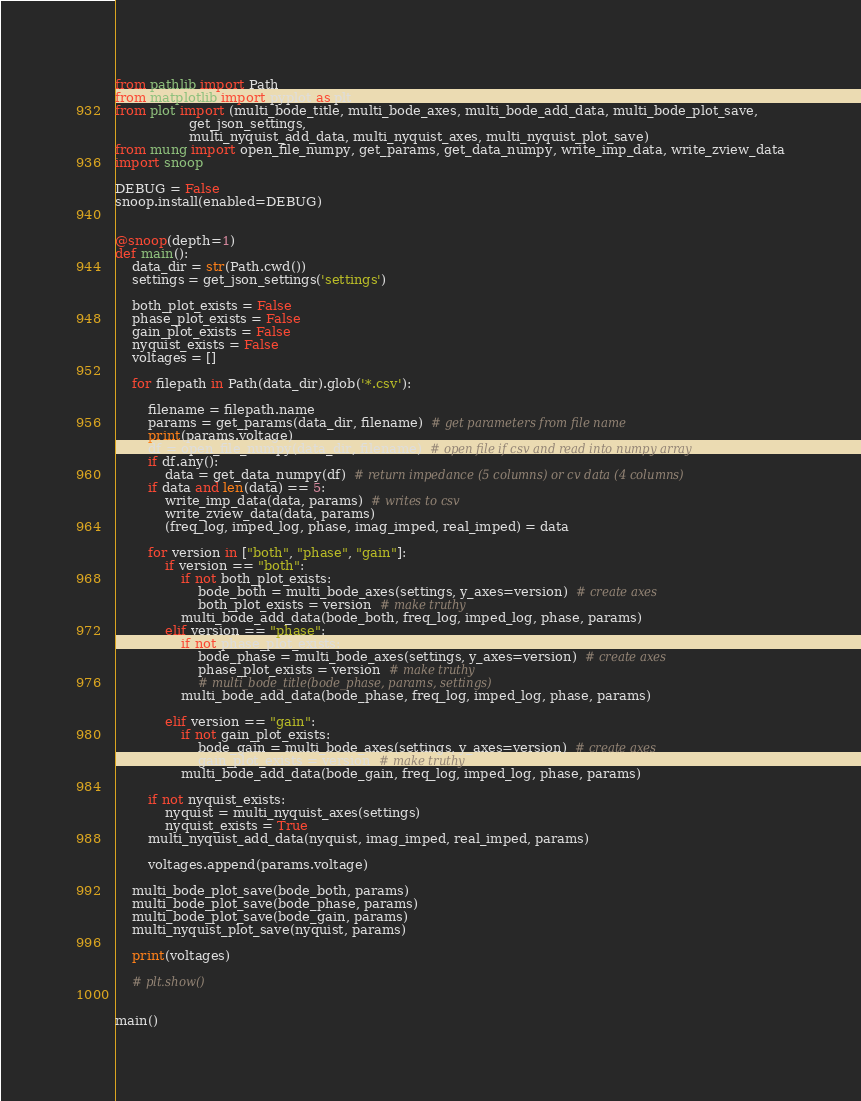Convert code to text. <code><loc_0><loc_0><loc_500><loc_500><_Python_>from pathlib import Path
from matplotlib import pyplot as plt
from plot import (multi_bode_title, multi_bode_axes, multi_bode_add_data, multi_bode_plot_save,
                  get_json_settings,
                  multi_nyquist_add_data, multi_nyquist_axes, multi_nyquist_plot_save)
from mung import open_file_numpy, get_params, get_data_numpy, write_imp_data, write_zview_data
import snoop

DEBUG = False
snoop.install(enabled=DEBUG)


@snoop(depth=1)
def main():
    data_dir = str(Path.cwd())
    settings = get_json_settings('settings')

    both_plot_exists = False
    phase_plot_exists = False
    gain_plot_exists = False
    nyquist_exists = False
    voltages = []

    for filepath in Path(data_dir).glob('*.csv'):

        filename = filepath.name
        params = get_params(data_dir, filename)  # get parameters from file name
        print(params.voltage)
        df = open_file_numpy(data_dir, filename)  # open file if csv and read into numpy array
        if df.any():
            data = get_data_numpy(df)  # return impedance (5 columns) or cv data (4 columns)
        if data and len(data) == 5:
            write_imp_data(data, params)  # writes to csv
            write_zview_data(data, params)
            (freq_log, imped_log, phase, imag_imped, real_imped) = data

        for version in ["both", "phase", "gain"]:
            if version == "both":
                if not both_plot_exists:
                    bode_both = multi_bode_axes(settings, y_axes=version)  # create axes
                    both_plot_exists = version  # make truthy
                multi_bode_add_data(bode_both, freq_log, imped_log, phase, params)
            elif version == "phase":
                if not phase_plot_exists:
                    bode_phase = multi_bode_axes(settings, y_axes=version)  # create axes
                    phase_plot_exists = version  # make truthy
                    # multi_bode_title(bode_phase, params, settings)
                multi_bode_add_data(bode_phase, freq_log, imped_log, phase, params)

            elif version == "gain":
                if not gain_plot_exists:
                    bode_gain = multi_bode_axes(settings, y_axes=version)  # create axes
                    gain_plot_exists = version  # make truthy
                multi_bode_add_data(bode_gain, freq_log, imped_log, phase, params)

        if not nyquist_exists:
            nyquist = multi_nyquist_axes(settings)
            nyquist_exists = True
        multi_nyquist_add_data(nyquist, imag_imped, real_imped, params)

        voltages.append(params.voltage)

    multi_bode_plot_save(bode_both, params)
    multi_bode_plot_save(bode_phase, params)
    multi_bode_plot_save(bode_gain, params)
    multi_nyquist_plot_save(nyquist, params)

    print(voltages)

    # plt.show()


main()
</code> 